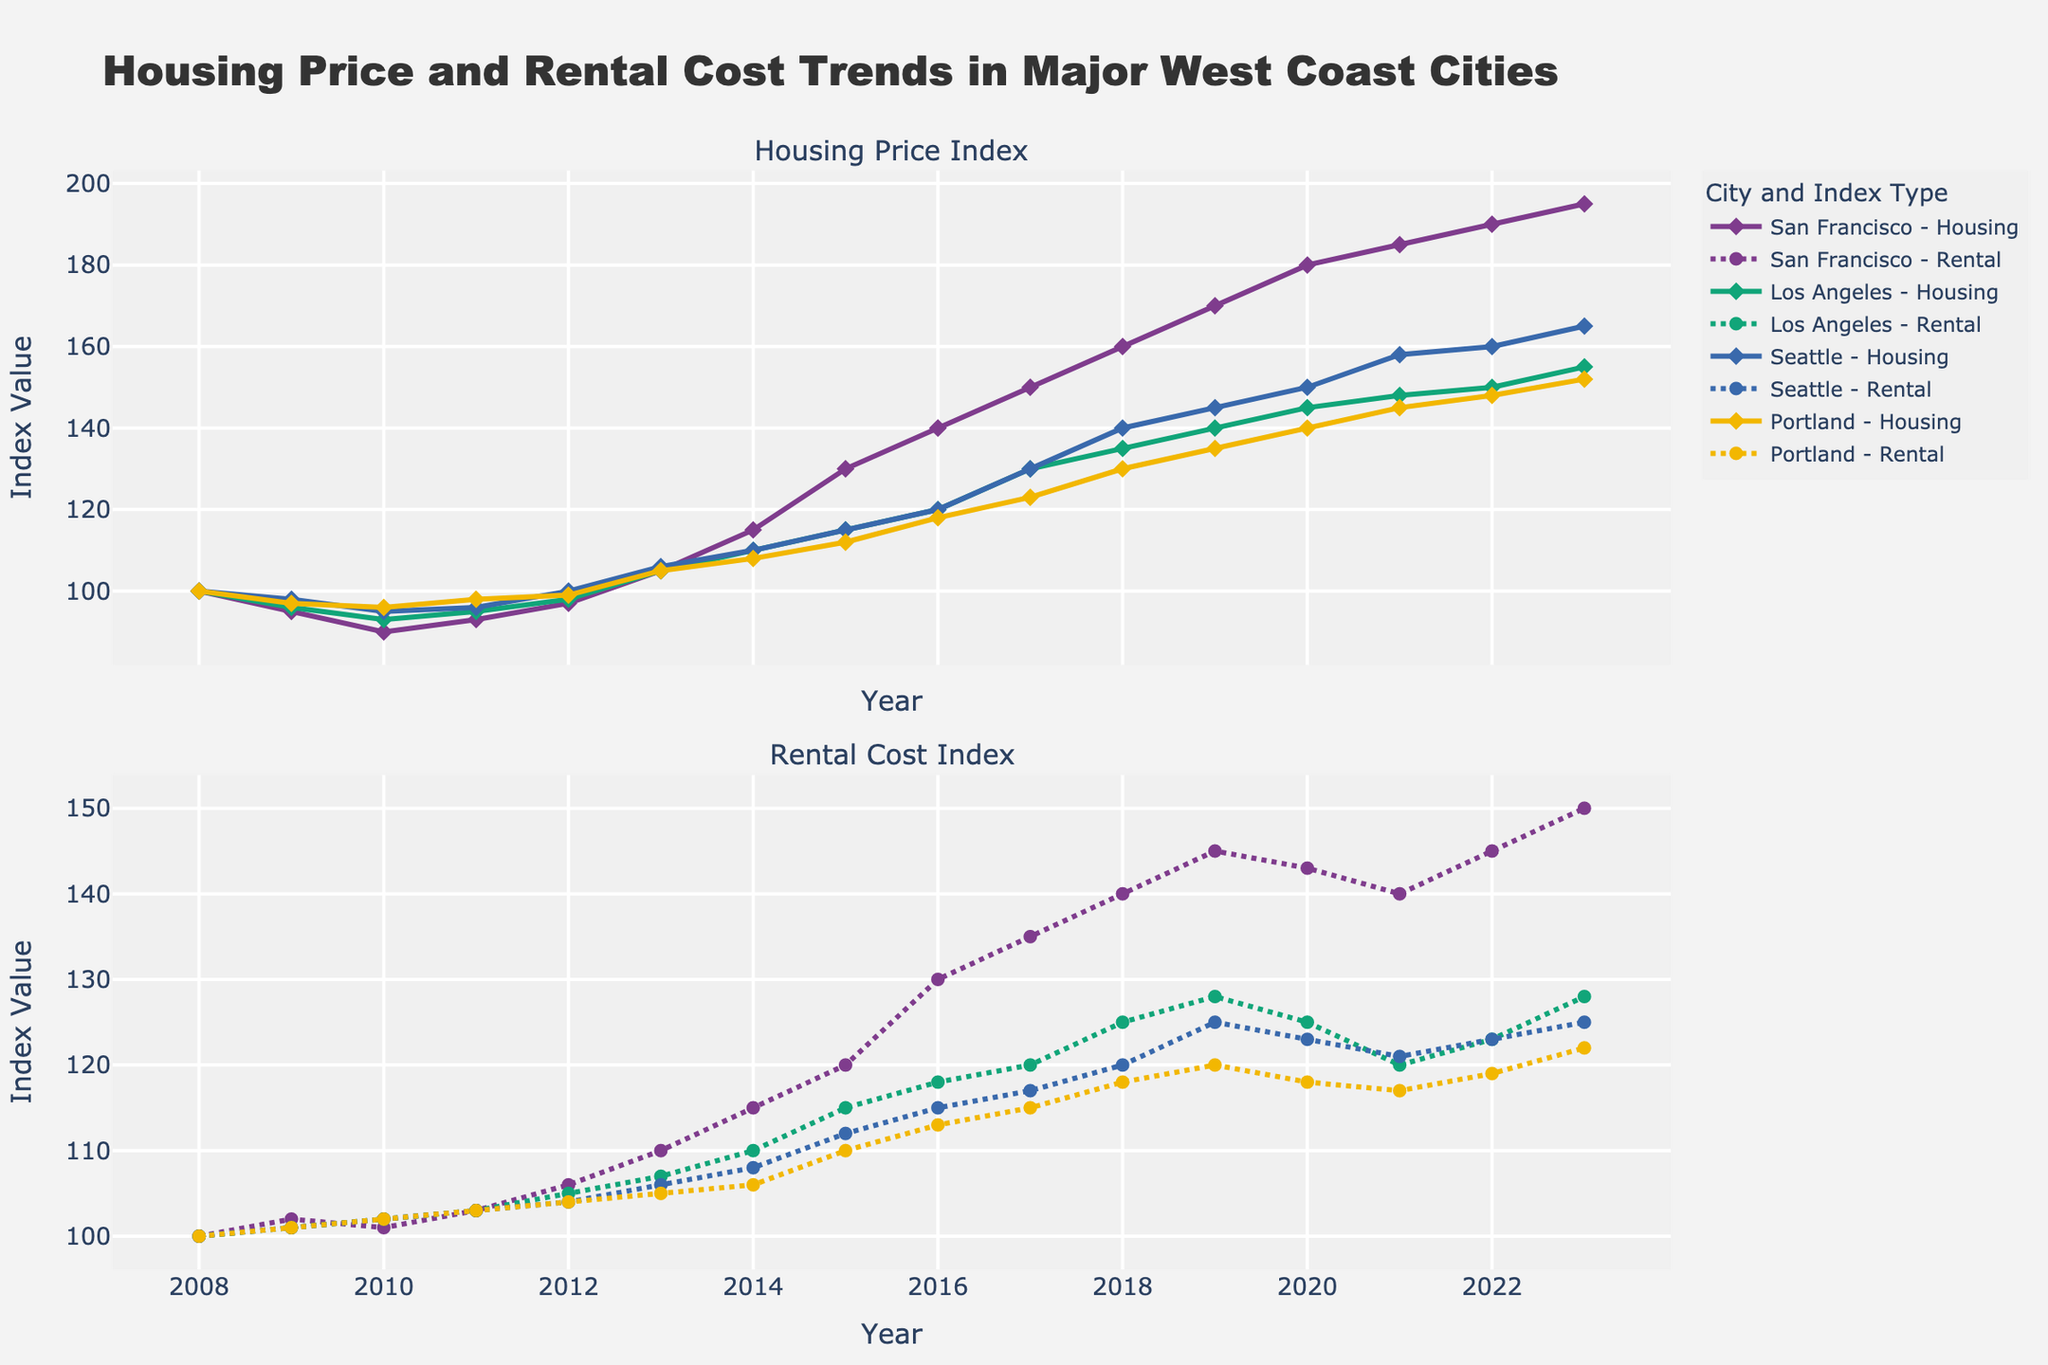Which city has the highest Housing Price Index in 2023? The plot shows the Housing Price Index trends for various cities. The highest value in 2023 is about 195, which belongs to San Francisco.
Answer: San Francisco What is the trend in Rental Cost Index for Portland from 2008 to 2023? The plot shows the Rental Cost Index trends for Portland from 2008 to 2023. The index generally increases from 100 in 2008 to 122 in 2023, indicating a rising trend with minor fluctuations.
Answer: Increasing How much did the Housing Price Index for Los Angeles change between 2008 and 2023? The Housing Price Index for Los Angeles was 100 in 2008 and increased to 155 in 2023. The change is 155 - 100 = 55.
Answer: 55 Which city had the most significant increase in Rental Cost Index over the 15 years? Comparing the Rental Cost Index changes from 2008 to 2023 across cities, San Francisco had an increase from 100 to 150, which is the highest among the cities, showing a 50-point increase.
Answer: San Francisco What was the Rental Cost Index for Seattle in 2021, and how does it compare to the 2023 value? For Seattle, the Rental Cost Index was 121 in 2021. By 2023, it increased to 125. The difference is 125 - 121 = 4.
Answer: 4 Which year did San Francisco see the most significant relative increase in Housing Price Index? Observing the plot, San Francisco's Housing Price Index saw the most substantial increase from 2012 to 2013, where it jumped from 97 to 105, an 8-point relative increase.
Answer: 2013 Identify the city with the least variation in Rental Cost Index over 15 years and state the range of variation. Portland shows the least variation in its Rental Cost Index, fluctuating from 100 in 2008 to 122 in 2023. The range of variation is 122 - 100 = 22.
Answer: Portland, 22 How do the 2023 Housing Price Indices for Seattle and Los Angeles compare? The plot shows the Housing Price Index for Seattle is 165, and for Los Angeles, it is 155 in 2023. Thus, Seattle's index is 10 points higher than Los Angeles's.
Answer: Seattle is 10 points higher 